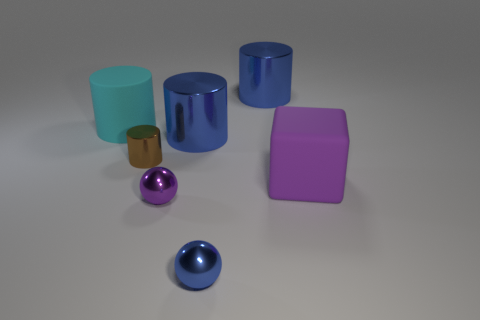Subtract all big cyan matte cylinders. How many cylinders are left? 3 Subtract all cyan cylinders. How many cylinders are left? 3 Subtract 3 cylinders. How many cylinders are left? 1 Subtract all spheres. How many objects are left? 5 Add 2 big purple objects. How many big purple objects exist? 3 Add 2 metallic cylinders. How many objects exist? 9 Subtract 1 brown cylinders. How many objects are left? 6 Subtract all blue cylinders. Subtract all red spheres. How many cylinders are left? 2 Subtract all purple cylinders. How many red balls are left? 0 Subtract all purple shiny spheres. Subtract all big blue metallic things. How many objects are left? 4 